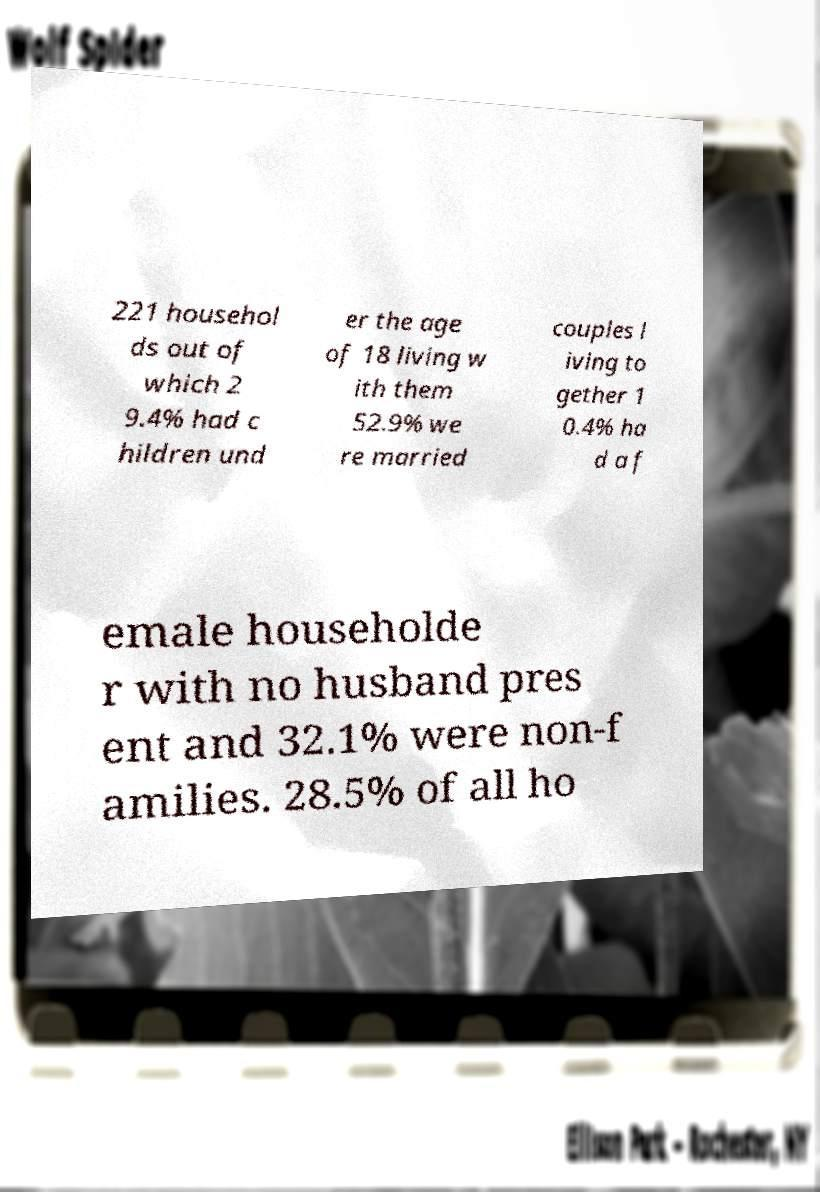Can you accurately transcribe the text from the provided image for me? 221 househol ds out of which 2 9.4% had c hildren und er the age of 18 living w ith them 52.9% we re married couples l iving to gether 1 0.4% ha d a f emale householde r with no husband pres ent and 32.1% were non-f amilies. 28.5% of all ho 